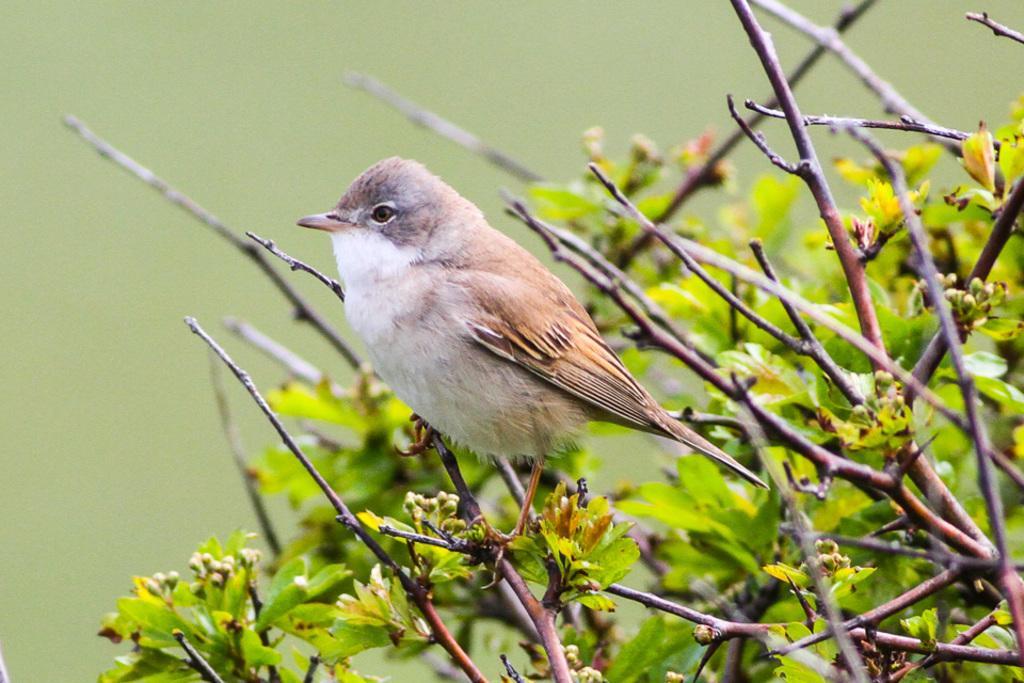Describe this image in one or two sentences. In this picture we can observe a bird on the land. The bird is in white and brown color. We can observe plant. In the background it is completely blur. 